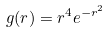Convert formula to latex. <formula><loc_0><loc_0><loc_500><loc_500>g ( r ) = r ^ { 4 } e ^ { - r ^ { 2 } }</formula> 